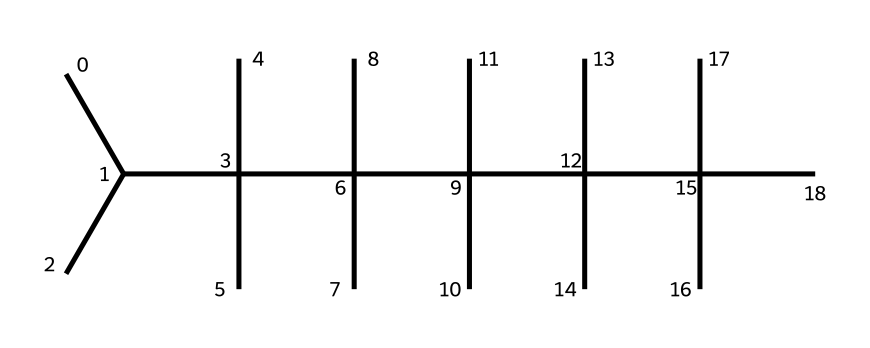How many carbon atoms are in this structure? By analyzing the SMILES representation, the 'C' indicates carbon atoms, and counting them in the structure gives a total of 30 carbon atoms.
Answer: 30 What is the primary type of polymer represented by this structure? The structure indicates a branched aliphatic polymer, typical of polyolefins, specifically a type of polypropylene.
Answer: polypropylene How many branches does the polymer contain? In the SMILES, for every tertiary carbon (indicated by the branching), there are multiple carbon chains attached; counting reveals there are 15 branches in total.
Answer: 15 What property is enhanced by the branched structure of this polymer? The branched structure typically enhances the density and flexibility of the polymer, which is crucial for its use in formulating vinyl records.
Answer: flexibility How does the structure influence the durability of vinyl records? The high degree of branching in this polymer structure improves its resistance to cracking and overall durability, making it suitable for repeated play in a DJ setting.
Answer: resistance What type of functional groups are present in this polymer? The polymer structure predominantly comprises only carbon and hydrogen atoms, indicating it lacks any specific functional groups like -OH or -COOH, typical in many other polymers.
Answer: none 